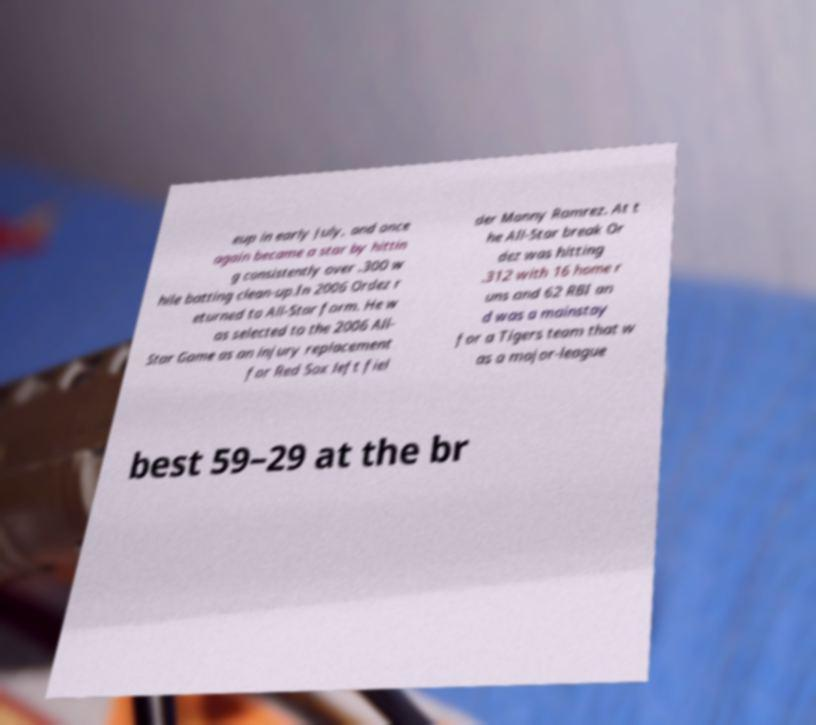Please read and relay the text visible in this image. What does it say? eup in early July, and once again became a star by hittin g consistently over .300 w hile batting clean-up.In 2006 Ordez r eturned to All-Star form. He w as selected to the 2006 All- Star Game as an injury replacement for Red Sox left fiel der Manny Ramrez. At t he All-Star break Or dez was hitting .312 with 16 home r uns and 62 RBI an d was a mainstay for a Tigers team that w as a major-league best 59–29 at the br 